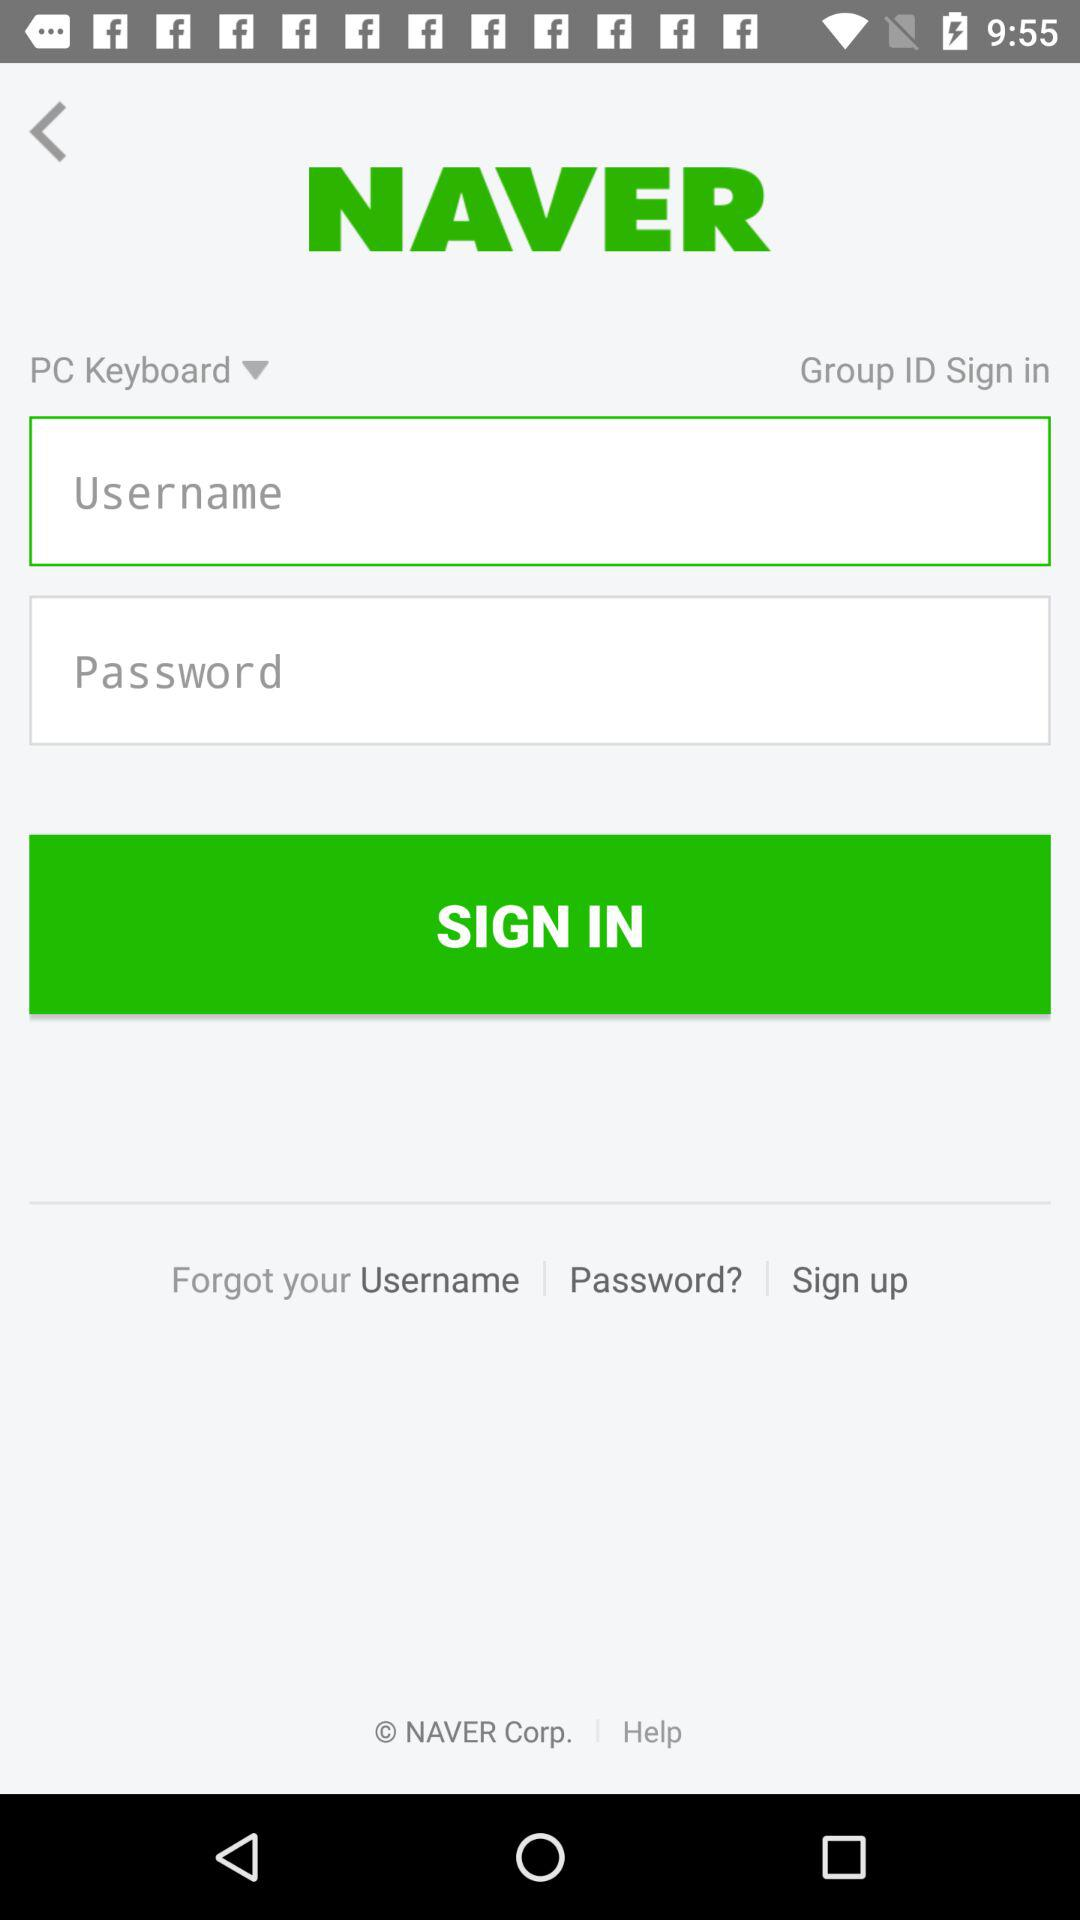What is the application name? The application name is "NAVER". 